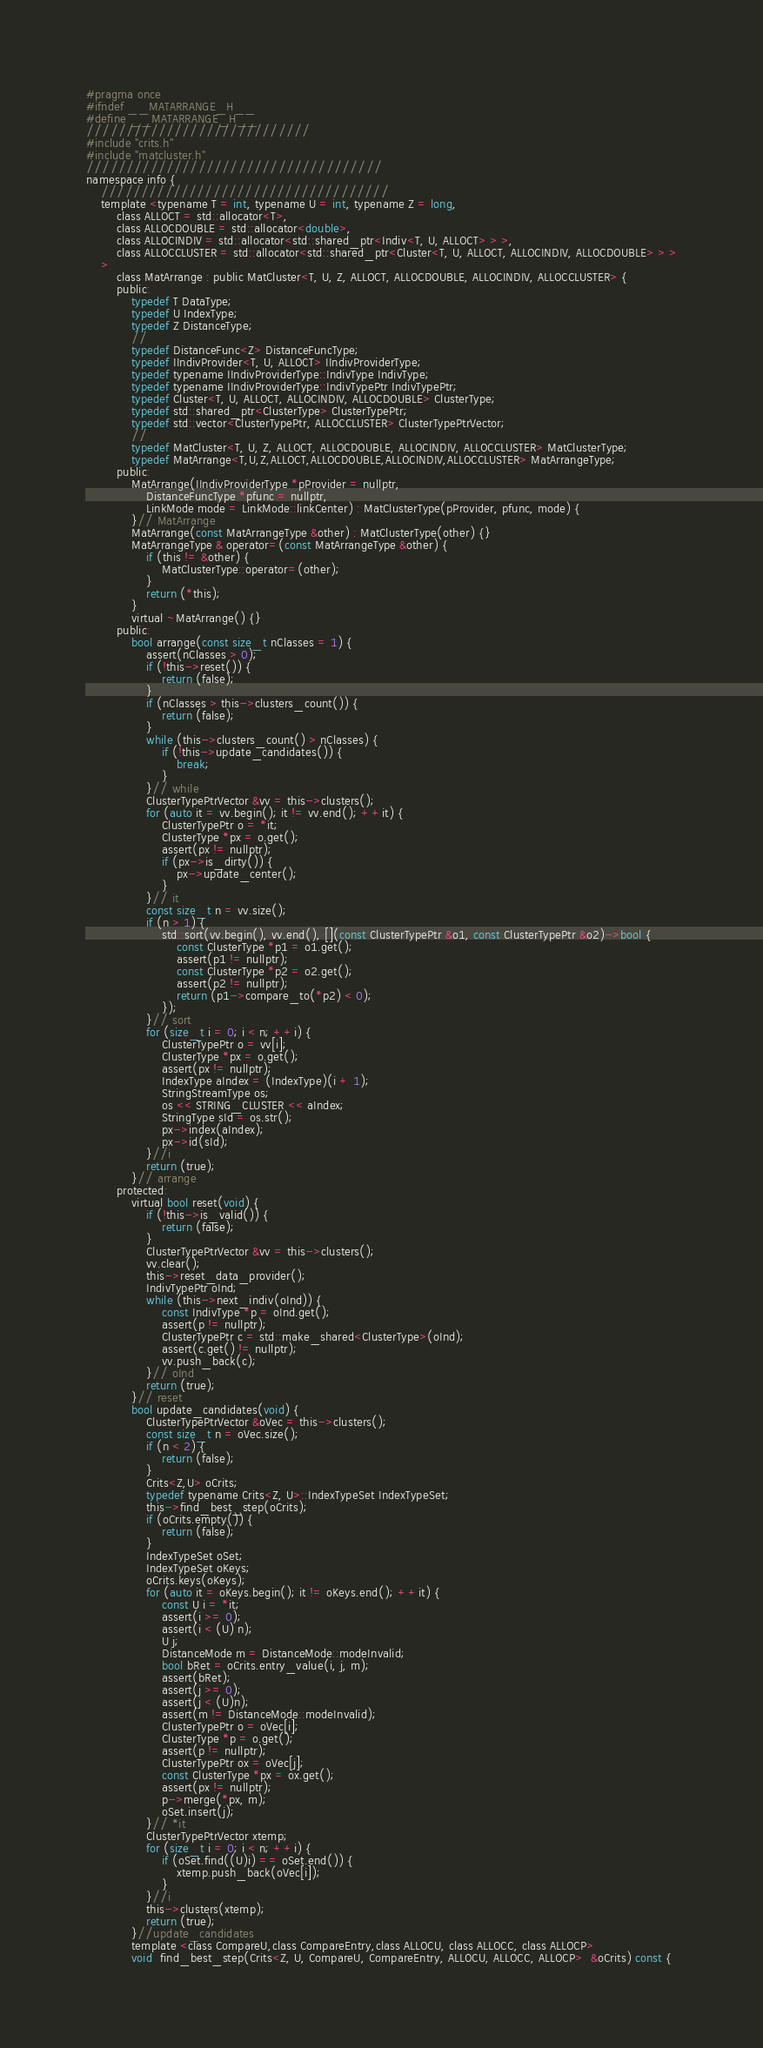Convert code to text. <code><loc_0><loc_0><loc_500><loc_500><_C_>#pragma once
#ifndef __MATARRANGE_H__
#define __MATARRANGE_H__
////////////////////////////
#include "crits.h"
#include "matcluster.h"
/////////////////////////////////////
namespace info {
	////////////////////////////////////
	template <typename T = int, typename U = int, typename Z = long,
		class ALLOCT = std::allocator<T>,
		class ALLOCDOUBLE = std::allocator<double>,
		class ALLOCINDIV = std::allocator<std::shared_ptr<Indiv<T, U, ALLOCT> > >,
		class ALLOCCLUSTER = std::allocator<std::shared_ptr<Cluster<T, U, ALLOCT, ALLOCINDIV, ALLOCDOUBLE> > >
	>
		class MatArrange : public MatCluster<T, U, Z, ALLOCT, ALLOCDOUBLE, ALLOCINDIV, ALLOCCLUSTER> {
		public:
			typedef T DataType;
			typedef U IndexType;
			typedef Z DistanceType;
			//
			typedef DistanceFunc<Z> DistanceFuncType;
			typedef IIndivProvider<T, U, ALLOCT> IIndivProviderType;
			typedef typename IIndivProviderType::IndivType IndivType;
			typedef typename IIndivProviderType::IndivTypePtr IndivTypePtr;
			typedef Cluster<T, U, ALLOCT, ALLOCINDIV, ALLOCDOUBLE> ClusterType;
			typedef std::shared_ptr<ClusterType> ClusterTypePtr;
			typedef std::vector<ClusterTypePtr, ALLOCCLUSTER> ClusterTypePtrVector;
			//
			typedef MatCluster<T, U, Z, ALLOCT, ALLOCDOUBLE, ALLOCINDIV, ALLOCCLUSTER> MatClusterType;
			typedef MatArrange<T,U,Z,ALLOCT,ALLOCDOUBLE,ALLOCINDIV,ALLOCCLUSTER> MatArrangeType;
		public:
			MatArrange(IIndivProviderType *pProvider = nullptr,
				DistanceFuncType *pfunc = nullptr,
				LinkMode mode = LinkMode::linkCenter) : MatClusterType(pProvider, pfunc, mode) {
			}// MatArrange
			MatArrange(const MatArrangeType &other) : MatClusterType(other) {}
			MatArrangeType & operator=(const MatArrangeType &other) {
				if (this != &other) {
					MatClusterType::operator=(other);
				}
				return (*this);
			}
			virtual ~MatArrange() {}
		public:
			bool arrange(const size_t nClasses = 1) {
				assert(nClasses > 0);
				if (!this->reset()) {
					return (false);
				}
				if (nClasses > this->clusters_count()) {
					return (false);
				}
				while (this->clusters_count() > nClasses) {
					if (!this->update_candidates()) {
						break;
					}
				}// while
				ClusterTypePtrVector &vv = this->clusters();
				for (auto it = vv.begin(); it != vv.end(); ++it) {
					ClusterTypePtr o = *it;
					ClusterType *px = o.get();
					assert(px != nullptr);
					if (px->is_dirty()) {
						px->update_center();
					}
				}// it
				const size_t n = vv.size();
				if (n > 1) {
					std::sort(vv.begin(), vv.end(), [](const ClusterTypePtr &o1, const ClusterTypePtr &o2)->bool {
						const ClusterType *p1 = o1.get();
						assert(p1 != nullptr);
						const ClusterType *p2 = o2.get();
						assert(p2 != nullptr);
						return (p1->compare_to(*p2) < 0);
					});
				}// sort
				for (size_t i = 0; i < n; ++i) {
					ClusterTypePtr o = vv[i];
					ClusterType *px = o.get();
					assert(px != nullptr);
					IndexType aIndex = (IndexType)(i + 1);
					StringStreamType os;
					os << STRING_CLUSTER << aIndex;
					StringType sId = os.str();
					px->index(aIndex);
					px->id(sId);
				}//i
				return (true);
			}// arrange
		protected:
			virtual bool reset(void) {
				if (!this->is_valid()) {
					return (false);
				}
				ClusterTypePtrVector &vv = this->clusters();
				vv.clear();
				this->reset_data_provider();
				IndivTypePtr oInd;
				while (this->next_indiv(oInd)) {
					const IndivType *p = oInd.get();
					assert(p != nullptr);
					ClusterTypePtr c = std::make_shared<ClusterType>(oInd);
					assert(c.get() != nullptr);
					vv.push_back(c);
				}// oInd
				return (true);
			}// reset
			bool update_candidates(void) {
				ClusterTypePtrVector &oVec = this->clusters();
				const size_t n = oVec.size();
				if (n < 2) {
					return (false);
				}
				Crits<Z,U> oCrits;
				typedef typename Crits<Z, U>::IndexTypeSet IndexTypeSet;
				this->find_best_step(oCrits);
				if (oCrits.empty()) {
					return (false);
				}
				IndexTypeSet oSet;
				IndexTypeSet oKeys;
				oCrits.keys(oKeys);
				for (auto it = oKeys.begin(); it != oKeys.end(); ++it) {
					const U i = *it;
					assert(i >= 0);
					assert(i < (U) n);
					U j;
					DistanceMode m = DistanceMode::modeInvalid;
					bool bRet = oCrits.entry_value(i, j, m);
					assert(bRet);
					assert(j >= 0);
					assert(j < (U)n);
					assert(m != DistanceMode::modeInvalid);
					ClusterTypePtr o = oVec[i];
					ClusterType *p = o.get();
					assert(p != nullptr);
					ClusterTypePtr ox = oVec[j];
					const ClusterType *px = ox.get();
					assert(px != nullptr);
					p->merge(*px, m);
					oSet.insert(j);
				}// *it
				ClusterTypePtrVector xtemp;
				for (size_t i = 0; i < n; ++i) {
					if (oSet.find((U)i) == oSet.end()) {
						xtemp.push_back(oVec[i]);
					}
				}//i
				this->clusters(xtemp);
				return (true);
			}//update_candidates
			template <class CompareU,class CompareEntry,class ALLOCU, class ALLOCC, class ALLOCP>
			void  find_best_step(Crits<Z, U, CompareU, CompareEntry, ALLOCU, ALLOCC, ALLOCP>  &oCrits) const {</code> 